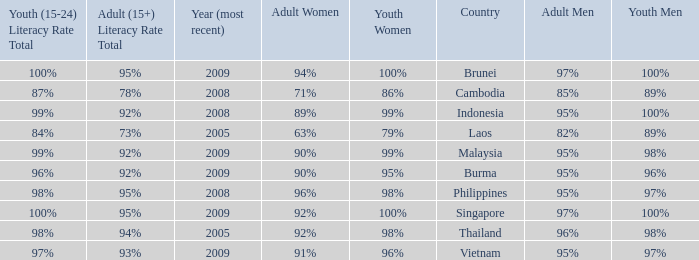Which country has its most recent year as being 2005 and has an Adult Men literacy rate of 96%? Thailand. 